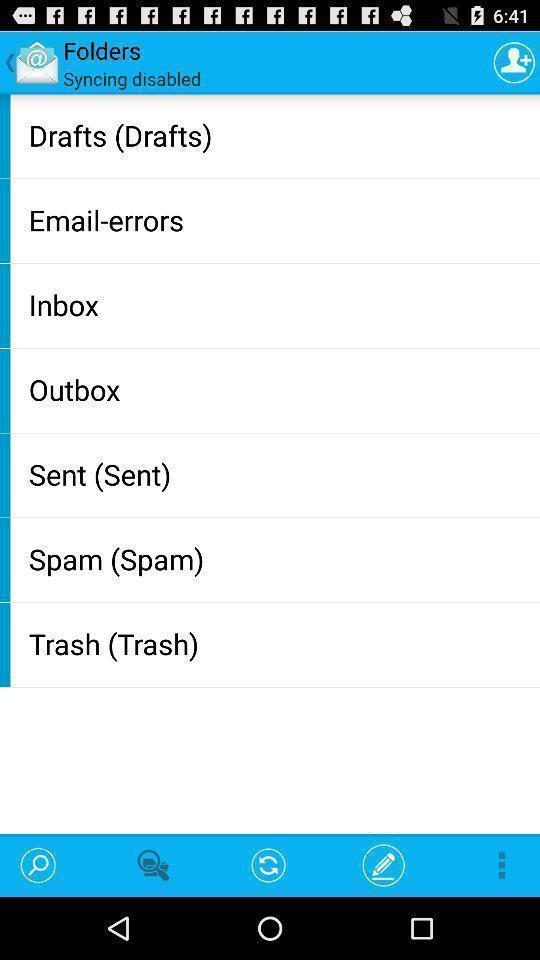Summarize the main components in this picture. Page showing different options in folders. 